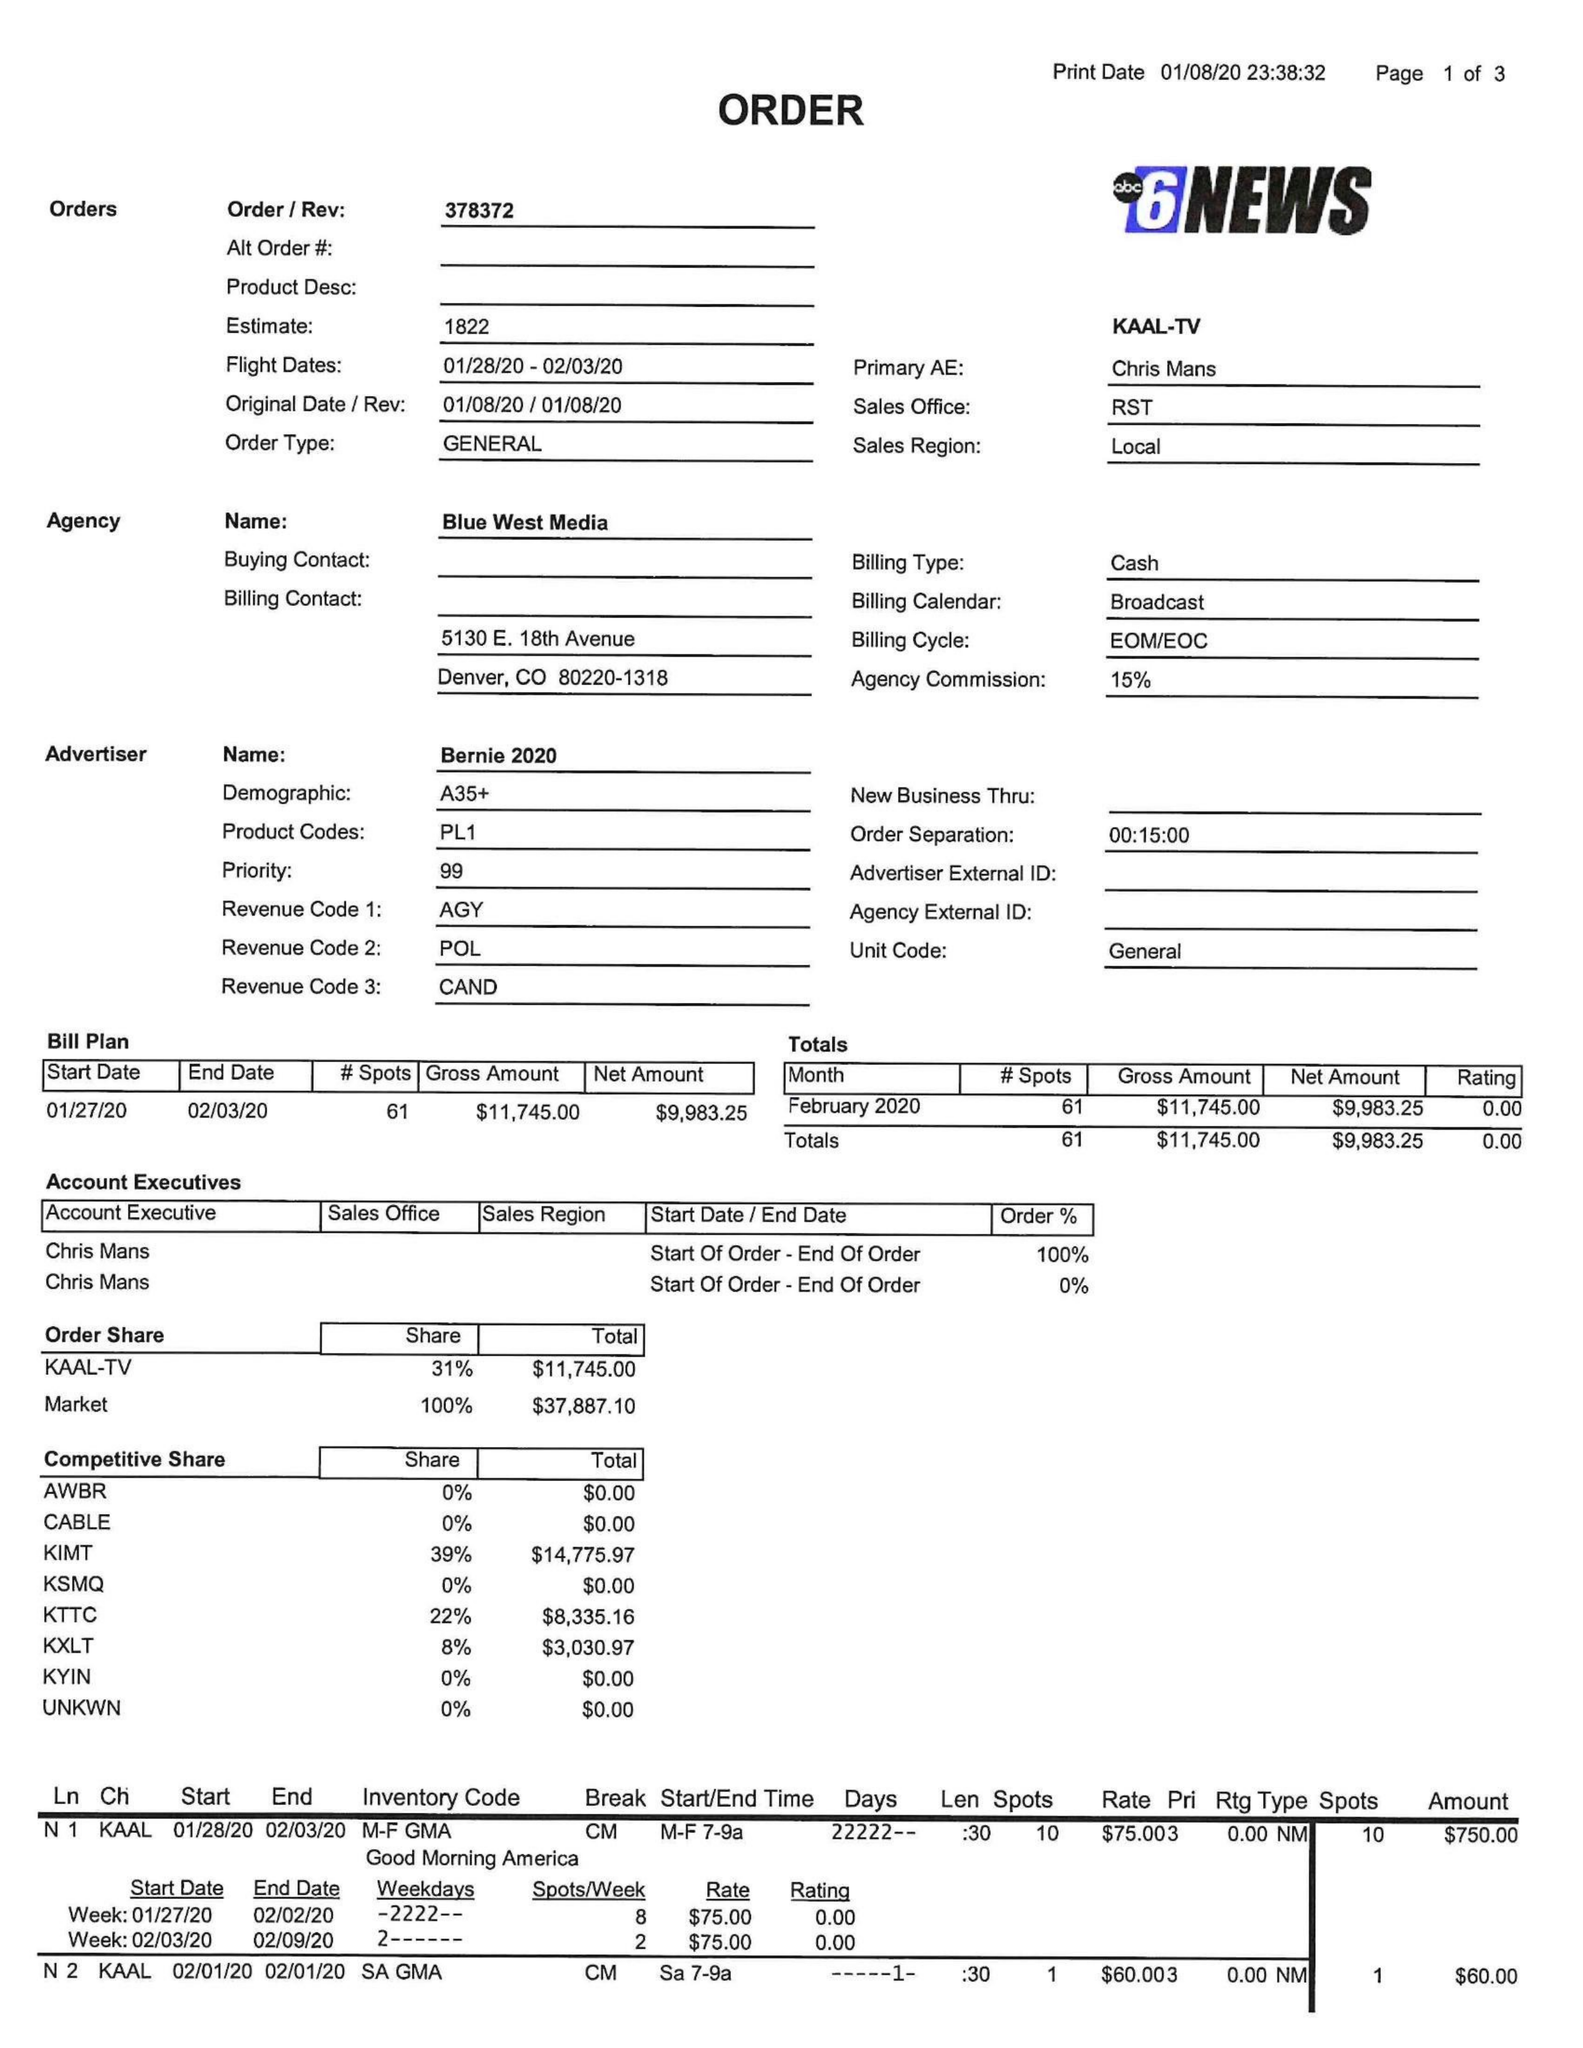What is the value for the flight_from?
Answer the question using a single word or phrase. 01/28/20 